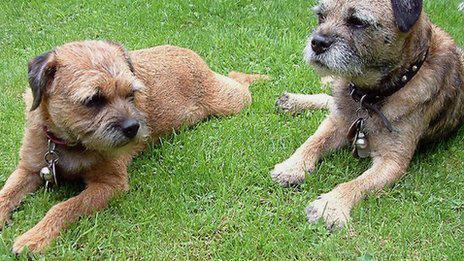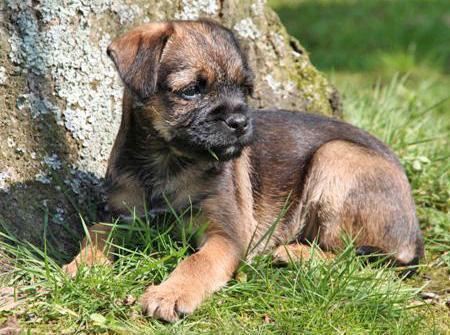The first image is the image on the left, the second image is the image on the right. Given the left and right images, does the statement "Three dogs are relaxing outside in the grass." hold true? Answer yes or no. Yes. The first image is the image on the left, the second image is the image on the right. Considering the images on both sides, is "There are three dogs exactly." valid? Answer yes or no. Yes. 